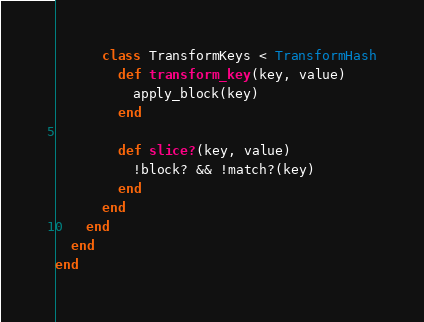<code> <loc_0><loc_0><loc_500><loc_500><_Ruby_>      class TransformKeys < TransformHash
        def transform_key(key, value)
          apply_block(key)
        end

        def slice?(key, value)
          !block? && !match?(key)
        end
      end
    end
  end
end
</code> 